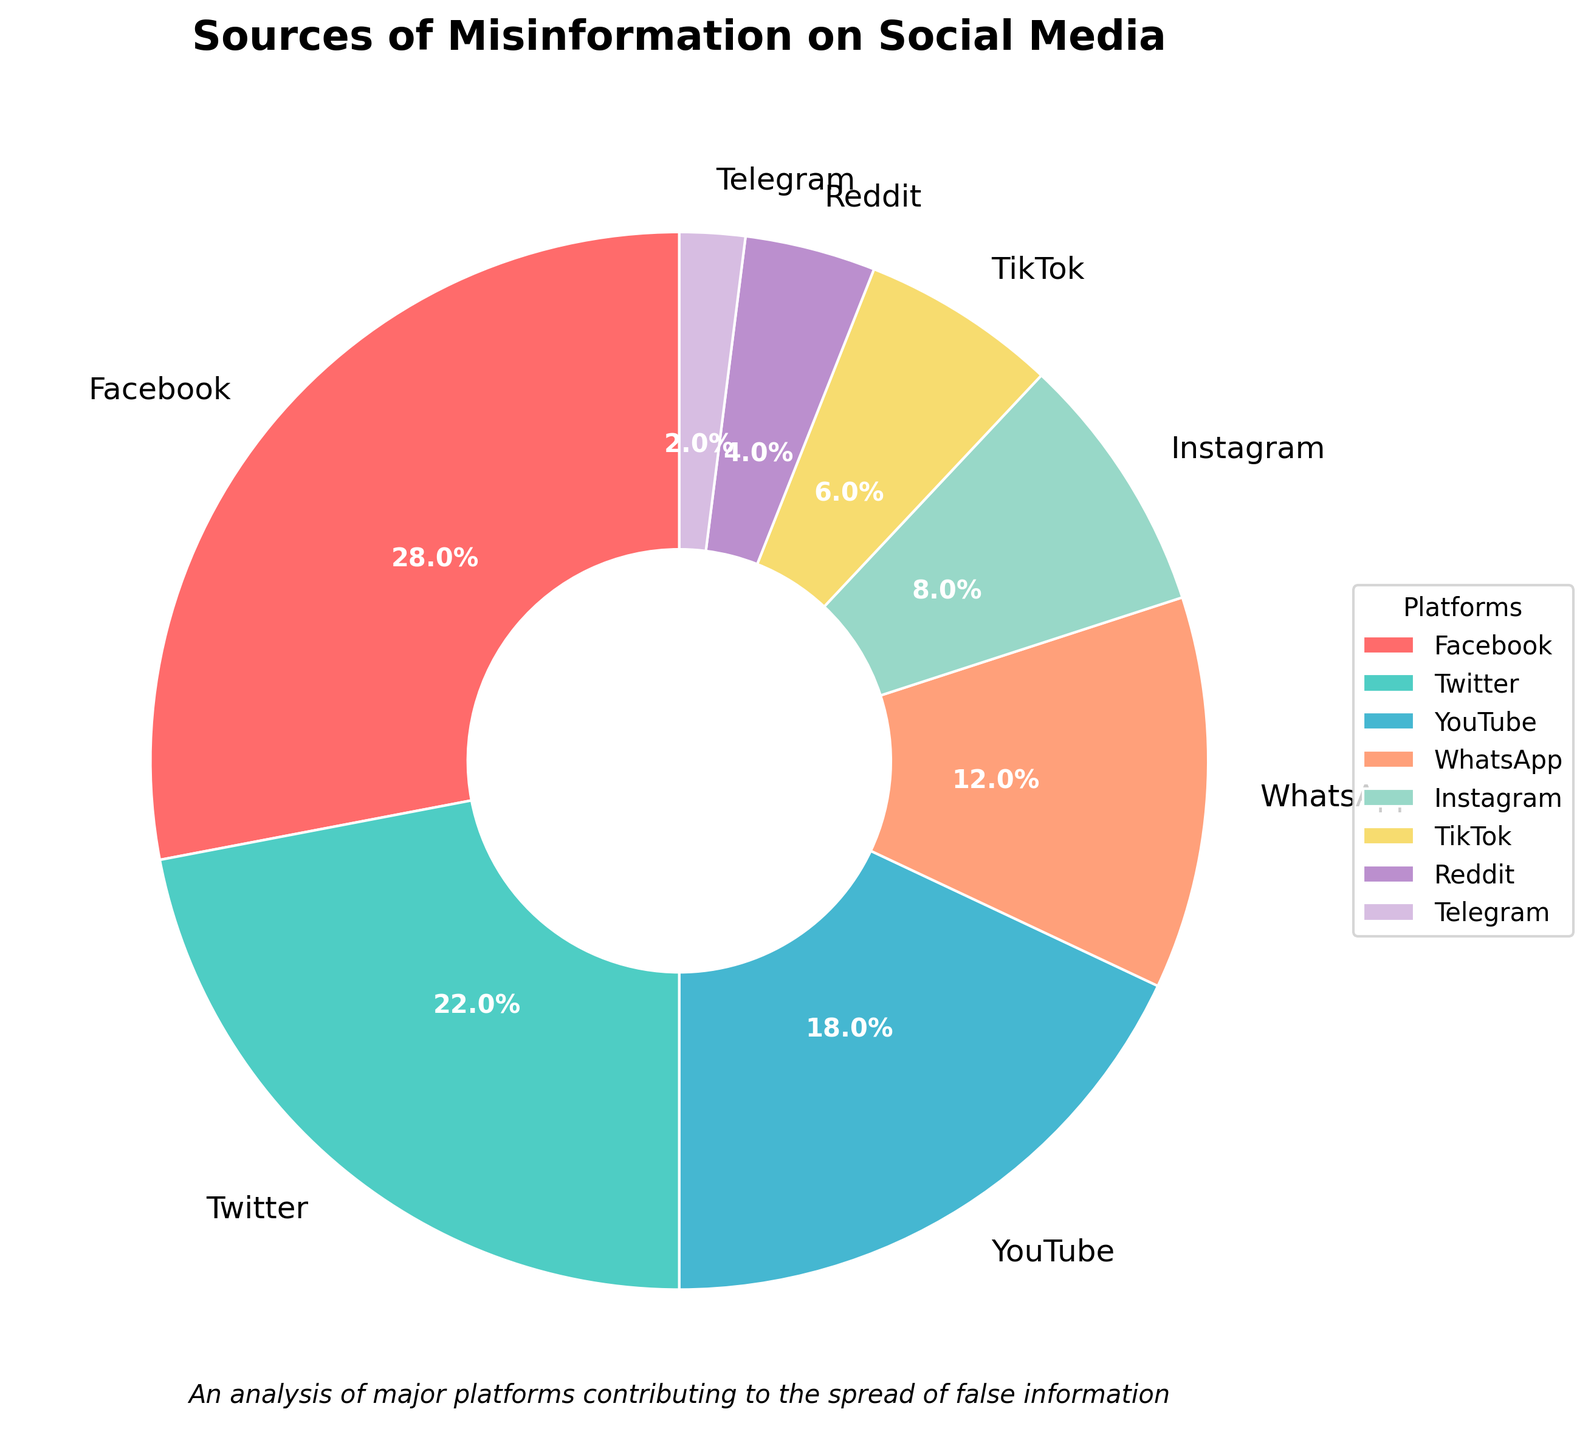What percentage of misinformation comes from Twitter? By looking at the pie chart, we can see that Twitter is labeled with a percentage of 22%.
Answer: 22% Which platform is responsible for the largest share of misinformation? The largest wedge in the pie chart is labeled "Facebook" with a 28% share.
Answer: Facebook How much more misinformation does Facebook contribute compared to TikTok? Facebook contributes 28%, and TikTok contributes 6%. The difference is 28% - 6% = 22%.
Answer: 22% Among Instagram, Reddit, and Telegram, which platform has the smallest share of misinformation? The wedges labeled Instagram, Reddit, and Telegram have shares of 8%, 4%, and 2% respectively. Telegram has the smallest share.
Answer: Telegram If you combine the percentages of misinformation from Facebook, YouTube, and Instagram, what do you get? Facebook contributes 28%, YouTube contributes 18%, and Instagram contributes 8%. Adding these together gives 28% + 18% + 8% = 54%.
Answer: 54% Out of WhatsApp and YouTube, which one contributes less misinformation? WhatsApp is labeled with 12%, and YouTube is labeled with 18%. Therefore, WhatsApp contributes less misinformation.
Answer: WhatsApp What is the total percentage of misinformation coming from YouTube, WhatsApp, and Instagram? YouTube contributes 18%, WhatsApp contributes 12%, and Instagram contributes 8%. Summing these yields 18% + 12% + 8% = 38%.
Answer: 38% Which platforms contribute less than 10% each to the misinformation? The wedges labeled with 8%, 6%, 4%, and 2% correspond to Instagram, TikTok, Reddit, and Telegram, respectively. They all contribute less than 10% each.
Answer: Instagram, TikTok, Reddit, Telegram What is the second-largest source of misinformation according to the chart? After examining the wedges, the second-largest percentage is 22%, which is labeled as Twitter.
Answer: Twitter How does the percentage contribution of misinformation by WhatsApp compare to that by Reddit and Telegram combined? WhatsApp contributes 12%, while Reddit and Telegram contribute 4% and 2%, respectively. The combined contribution of Reddit and Telegram is 4% + 2% = 6%, which is less than WhatsApp's 12%.
Answer: WhatsApp contributes more 